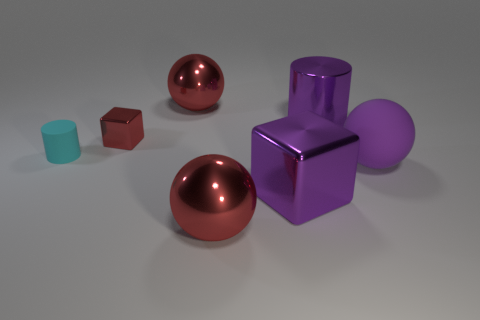Subtract all big metal balls. How many balls are left? 1 Subtract all balls. How many objects are left? 4 Subtract 2 balls. How many balls are left? 1 Subtract all green spheres. Subtract all purple cylinders. How many spheres are left? 3 Subtract all gray cylinders. How many blue blocks are left? 0 Subtract all cyan objects. Subtract all large cylinders. How many objects are left? 5 Add 4 small metal objects. How many small metal objects are left? 5 Add 1 small red objects. How many small red objects exist? 2 Add 1 rubber objects. How many objects exist? 8 Subtract all cyan cylinders. How many cylinders are left? 1 